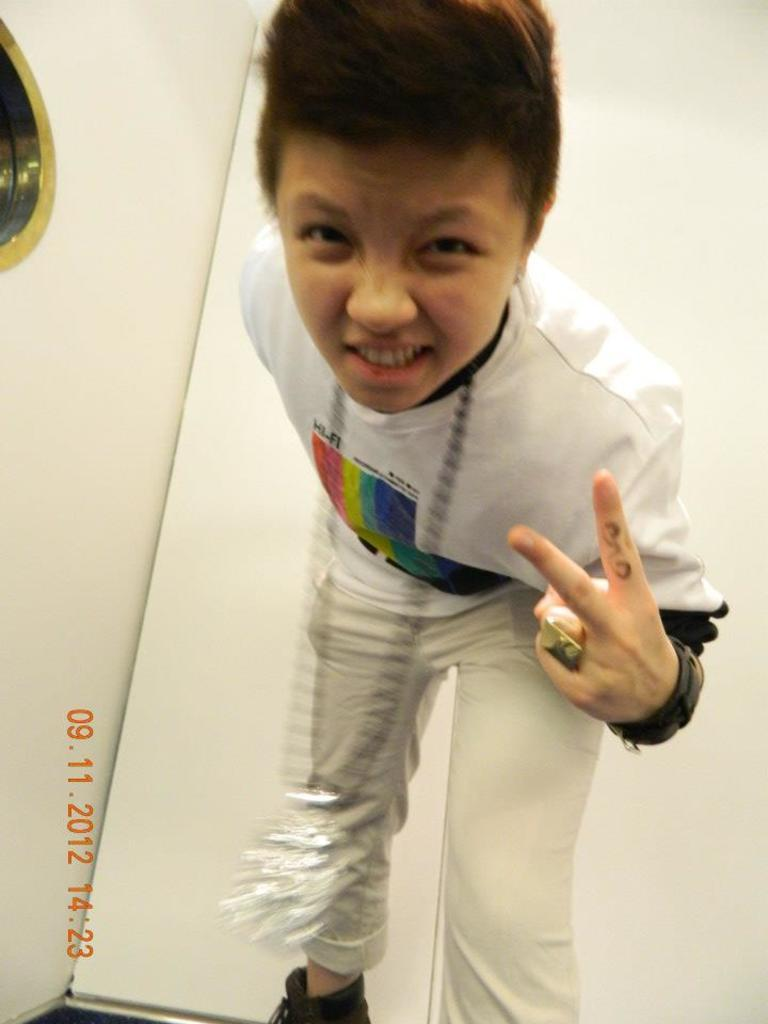Who or what is the main subject in the image? There is a person in the image. What can be seen in the background of the image? There are walls in the background of the image. How many spoons are visible in the image? There is no mention of spoons in the provided facts, so we cannot determine if any spoons are present in the image. 